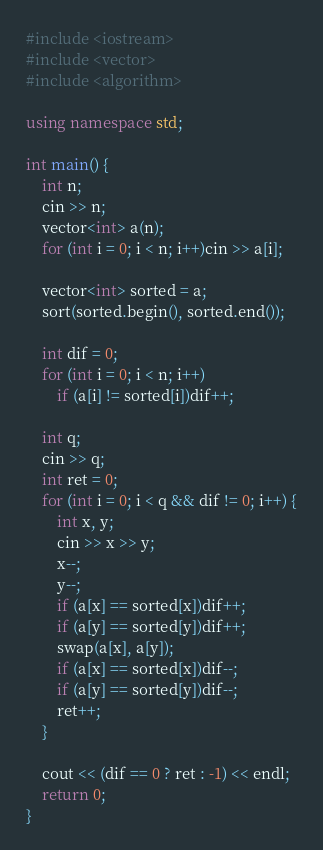Convert code to text. <code><loc_0><loc_0><loc_500><loc_500><_C++_>#include <iostream>
#include <vector>
#include <algorithm>

using namespace std;

int main() {
    int n;
    cin >> n;
    vector<int> a(n);
    for (int i = 0; i < n; i++)cin >> a[i];

    vector<int> sorted = a;
    sort(sorted.begin(), sorted.end());

    int dif = 0;
    for (int i = 0; i < n; i++)
        if (a[i] != sorted[i])dif++;

    int q;
    cin >> q;
    int ret = 0;
    for (int i = 0; i < q && dif != 0; i++) {
        int x, y;
        cin >> x >> y;
        x--;
        y--;
        if (a[x] == sorted[x])dif++;
        if (a[y] == sorted[y])dif++;
        swap(a[x], a[y]);
        if (a[x] == sorted[x])dif--;
        if (a[y] == sorted[y])dif--;
        ret++;
    }

    cout << (dif == 0 ? ret : -1) << endl;
    return 0;
}
</code> 